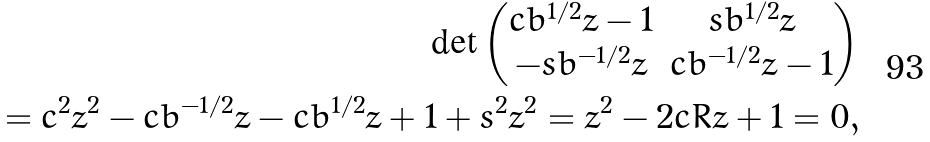Convert formula to latex. <formula><loc_0><loc_0><loc_500><loc_500>\det \begin{pmatrix} c b ^ { 1 / 2 } z - 1 & s b ^ { 1 / 2 } z \\ - s b ^ { - 1 / 2 } z & c b ^ { - 1 / 2 } z - 1 \end{pmatrix} \\ = c ^ { 2 } z ^ { 2 } - c b ^ { - 1 / 2 } z - c b ^ { 1 / 2 } z + 1 + s ^ { 2 } z ^ { 2 } = z ^ { 2 } - 2 c R z + 1 = 0 ,</formula> 